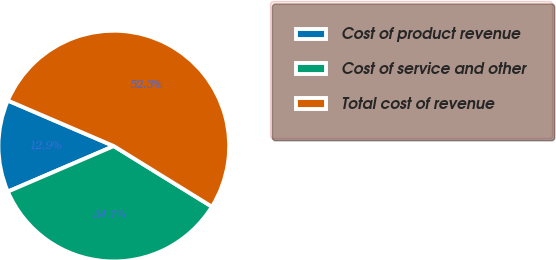Convert chart to OTSL. <chart><loc_0><loc_0><loc_500><loc_500><pie_chart><fcel>Cost of product revenue<fcel>Cost of service and other<fcel>Total cost of revenue<nl><fcel>12.92%<fcel>34.73%<fcel>52.35%<nl></chart> 